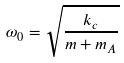<formula> <loc_0><loc_0><loc_500><loc_500>\omega _ { 0 } = \sqrt { \frac { k _ { c } } { m + m _ { A } } }</formula> 